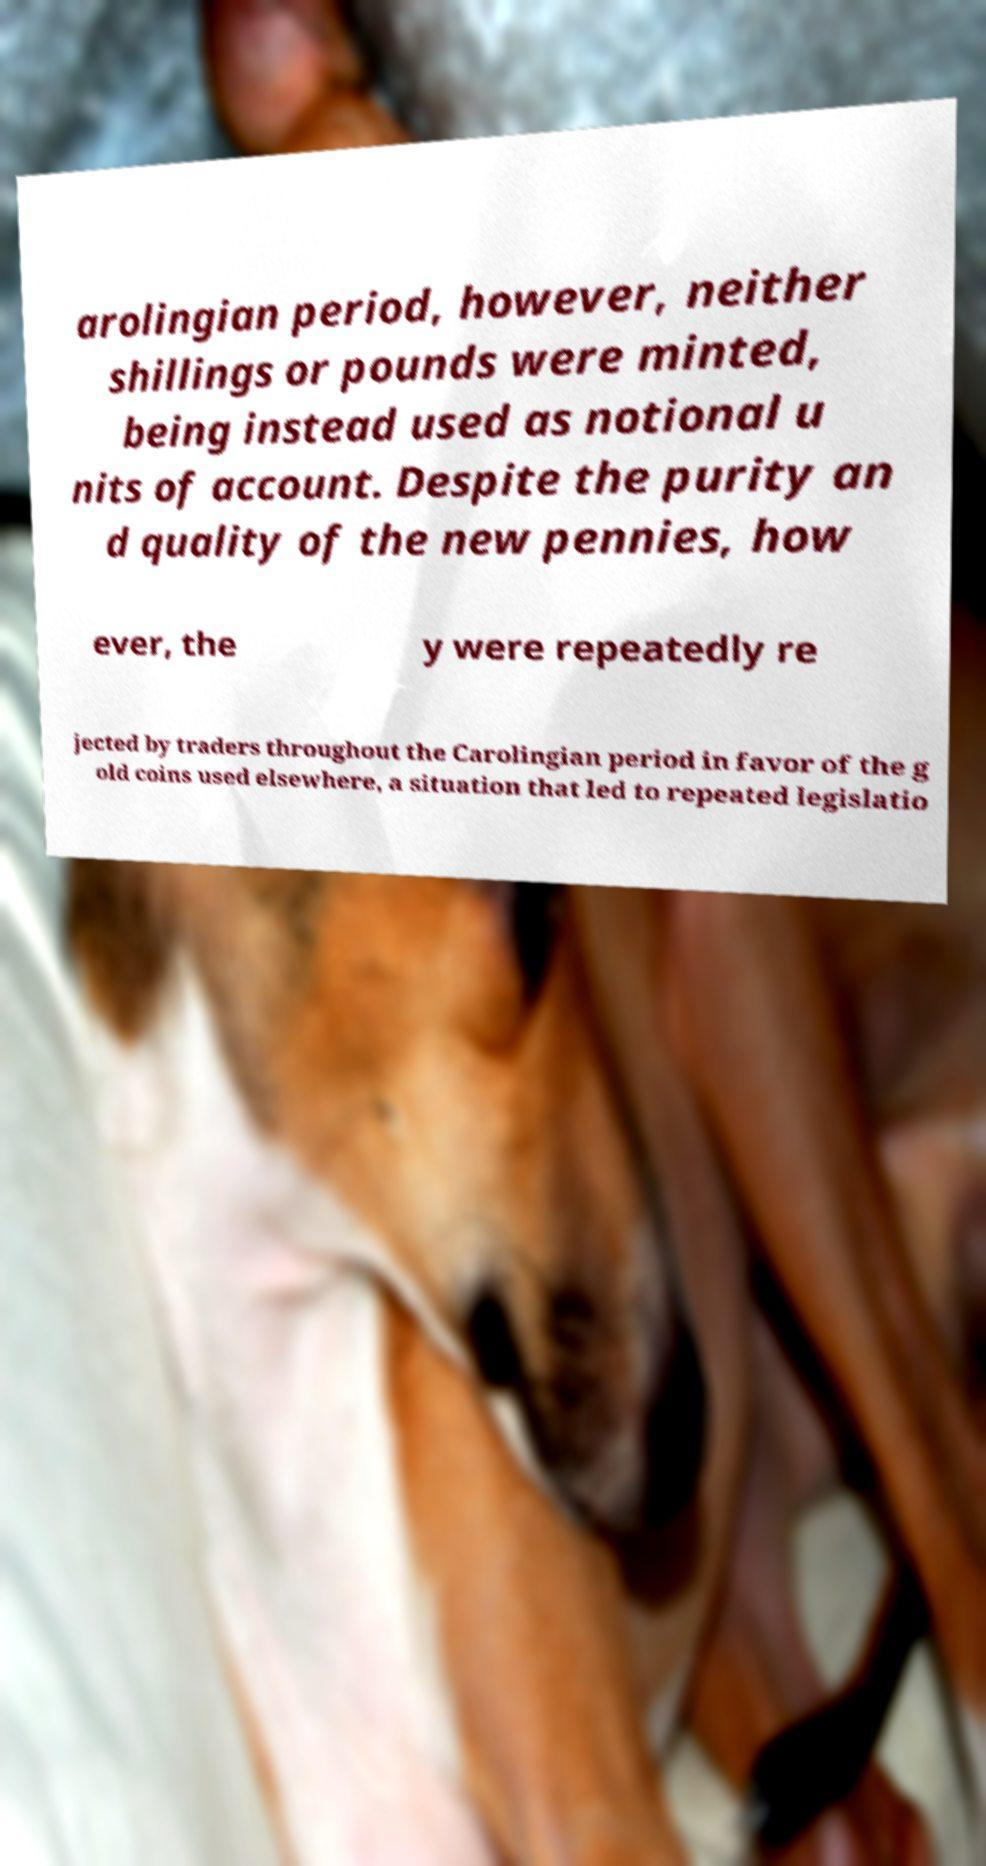Can you read and provide the text displayed in the image?This photo seems to have some interesting text. Can you extract and type it out for me? arolingian period, however, neither shillings or pounds were minted, being instead used as notional u nits of account. Despite the purity an d quality of the new pennies, how ever, the y were repeatedly re jected by traders throughout the Carolingian period in favor of the g old coins used elsewhere, a situation that led to repeated legislatio 